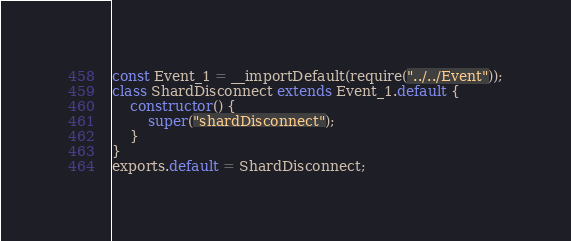Convert code to text. <code><loc_0><loc_0><loc_500><loc_500><_JavaScript_>const Event_1 = __importDefault(require("../../Event"));
class ShardDisconnect extends Event_1.default {
    constructor() {
        super("shardDisconnect");
    }
}
exports.default = ShardDisconnect;
</code> 